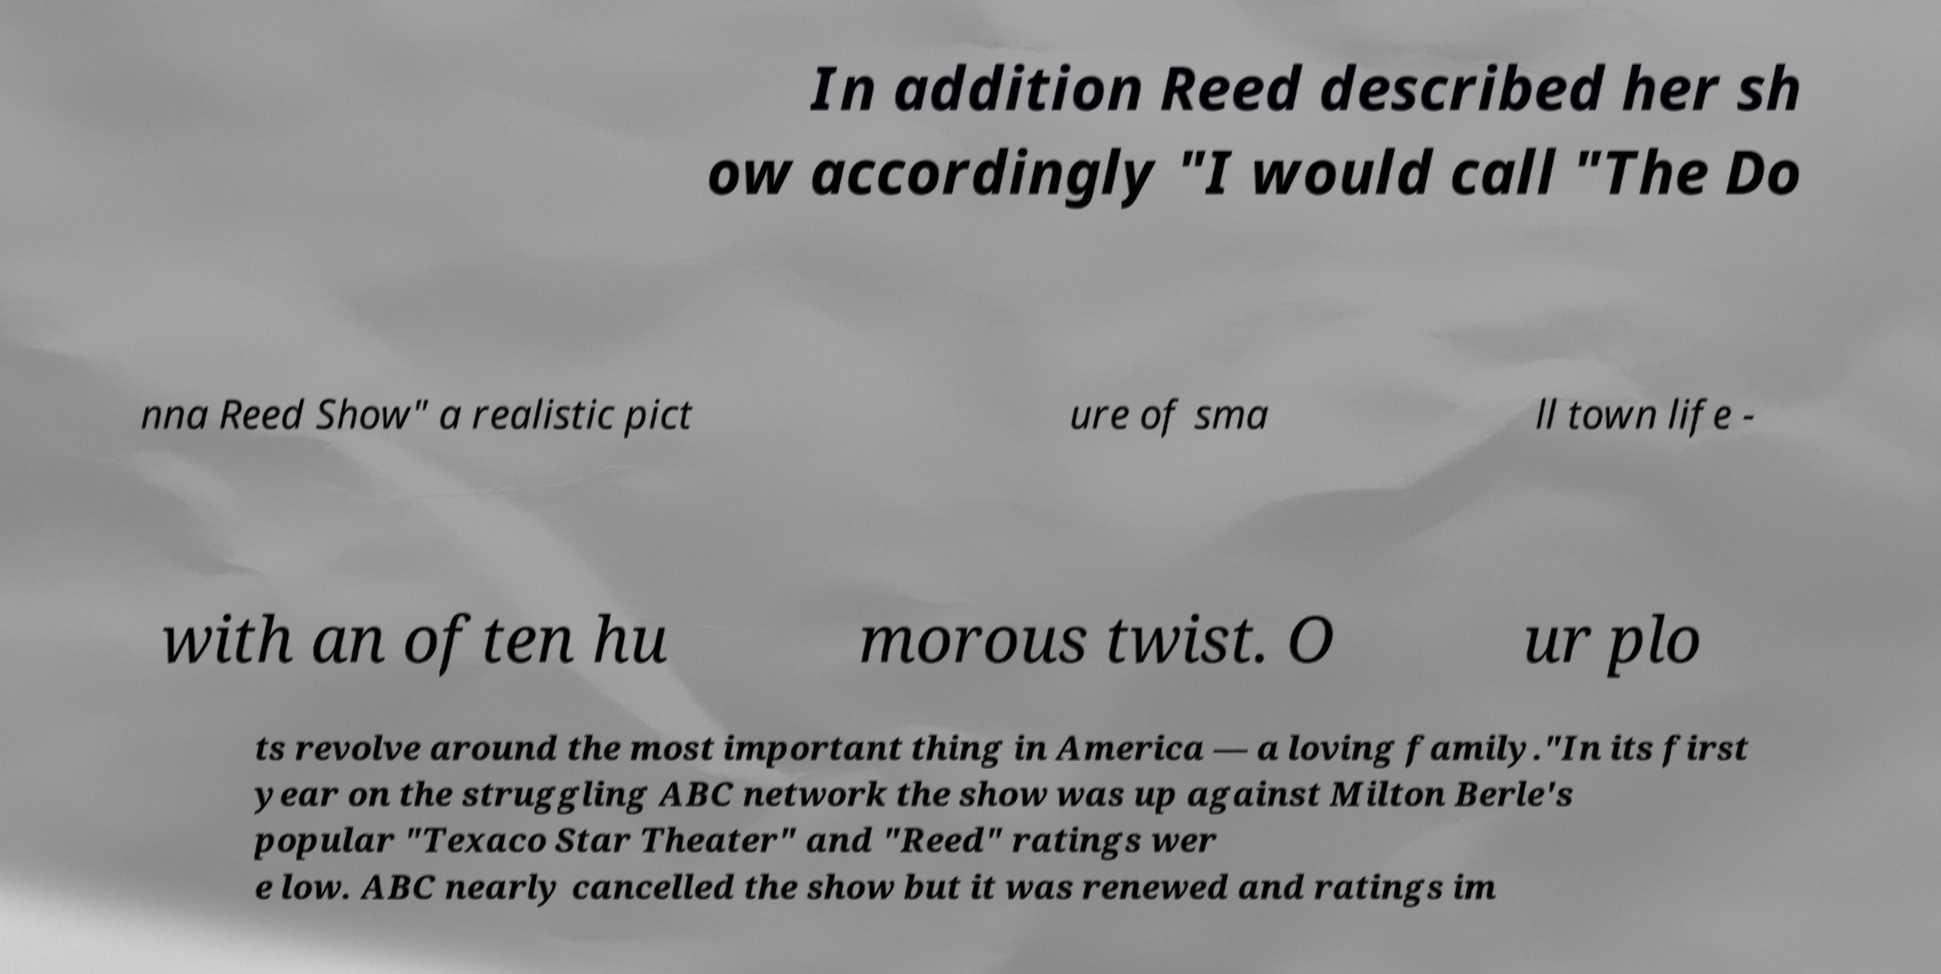Can you accurately transcribe the text from the provided image for me? In addition Reed described her sh ow accordingly "I would call "The Do nna Reed Show" a realistic pict ure of sma ll town life - with an often hu morous twist. O ur plo ts revolve around the most important thing in America — a loving family."In its first year on the struggling ABC network the show was up against Milton Berle's popular "Texaco Star Theater" and "Reed" ratings wer e low. ABC nearly cancelled the show but it was renewed and ratings im 